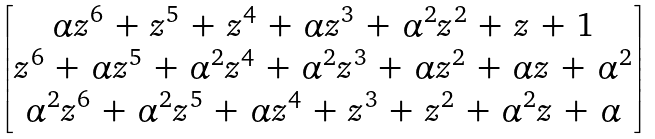Convert formula to latex. <formula><loc_0><loc_0><loc_500><loc_500>\begin{bmatrix} \alpha z ^ { 6 } \, + \, z ^ { 5 } \, + \, z ^ { 4 } \, + \, \alpha z ^ { 3 } \, + \, \alpha ^ { 2 } z ^ { 2 } \, + \, z \, + \, 1 \\ z ^ { 6 } \, + \, \alpha z ^ { 5 } \, + \, \alpha ^ { 2 } z ^ { 4 } \, + \, \alpha ^ { 2 } z ^ { 3 } \, + \, \alpha z ^ { 2 } \, + \, \alpha z \, + \, \alpha ^ { 2 } \\ \alpha ^ { 2 } z ^ { 6 } \, + \, \alpha ^ { 2 } z ^ { 5 } \, + \, \alpha z ^ { 4 } \, + \, z ^ { 3 } \, + \, z ^ { 2 } \, + \, \alpha ^ { 2 } z \, + \, \alpha \end{bmatrix}</formula> 